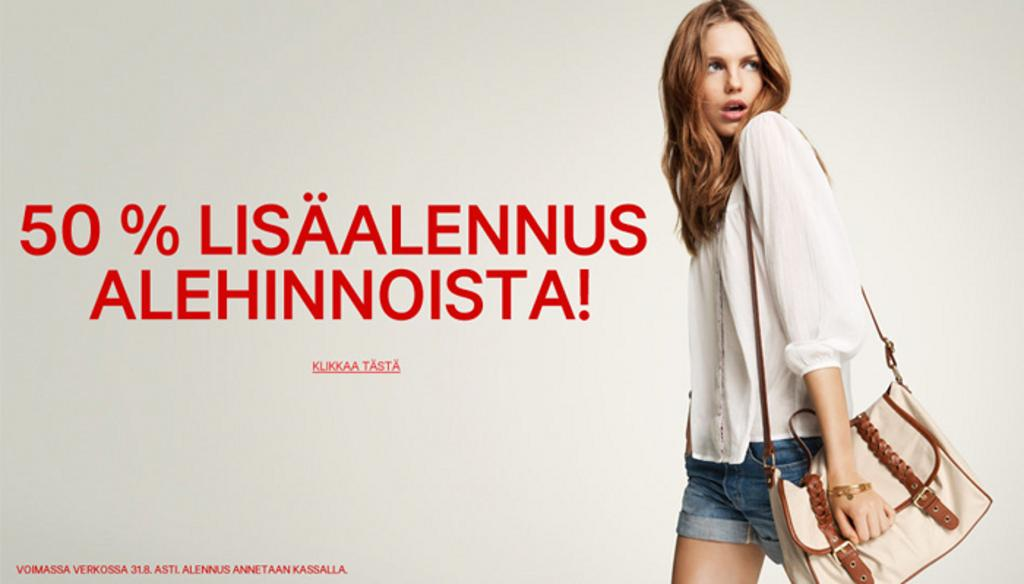Who is present in the image? There is a woman in the image. What is the woman wearing? The woman is wearing a white shirt. What is the woman carrying? The woman is carrying a sling bag. What is the woman doing in the image? The woman is walking. What can be seen in the background of the image? There is a wall in the image, and text is printed on the wall. What type of food is the woman cooking in the image? There is no indication in the image that the woman is cooking any food, so it cannot be determined from the picture. 